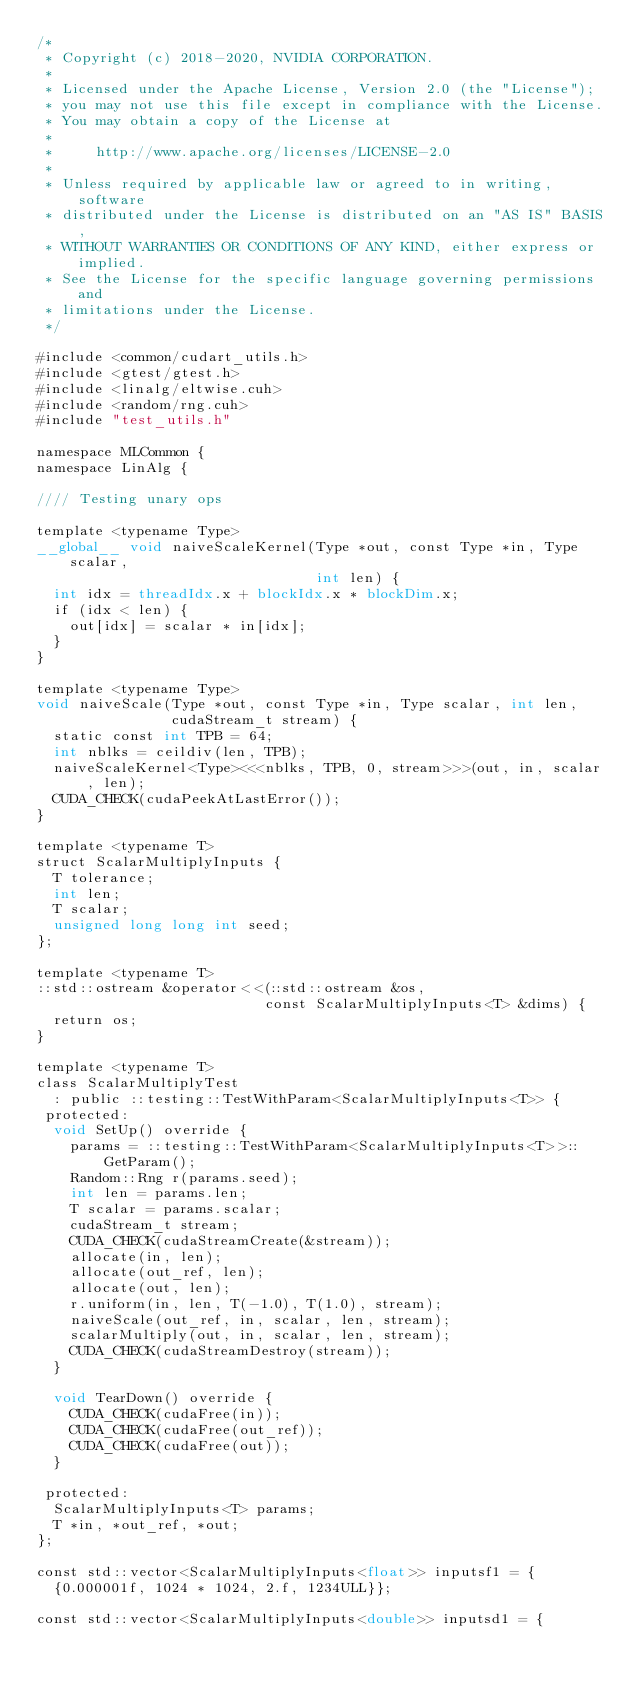<code> <loc_0><loc_0><loc_500><loc_500><_Cuda_>/*
 * Copyright (c) 2018-2020, NVIDIA CORPORATION.
 *
 * Licensed under the Apache License, Version 2.0 (the "License");
 * you may not use this file except in compliance with the License.
 * You may obtain a copy of the License at
 *
 *     http://www.apache.org/licenses/LICENSE-2.0
 *
 * Unless required by applicable law or agreed to in writing, software
 * distributed under the License is distributed on an "AS IS" BASIS,
 * WITHOUT WARRANTIES OR CONDITIONS OF ANY KIND, either express or implied.
 * See the License for the specific language governing permissions and
 * limitations under the License.
 */

#include <common/cudart_utils.h>
#include <gtest/gtest.h>
#include <linalg/eltwise.cuh>
#include <random/rng.cuh>
#include "test_utils.h"

namespace MLCommon {
namespace LinAlg {

//// Testing unary ops

template <typename Type>
__global__ void naiveScaleKernel(Type *out, const Type *in, Type scalar,
                                 int len) {
  int idx = threadIdx.x + blockIdx.x * blockDim.x;
  if (idx < len) {
    out[idx] = scalar * in[idx];
  }
}

template <typename Type>
void naiveScale(Type *out, const Type *in, Type scalar, int len,
                cudaStream_t stream) {
  static const int TPB = 64;
  int nblks = ceildiv(len, TPB);
  naiveScaleKernel<Type><<<nblks, TPB, 0, stream>>>(out, in, scalar, len);
  CUDA_CHECK(cudaPeekAtLastError());
}

template <typename T>
struct ScalarMultiplyInputs {
  T tolerance;
  int len;
  T scalar;
  unsigned long long int seed;
};

template <typename T>
::std::ostream &operator<<(::std::ostream &os,
                           const ScalarMultiplyInputs<T> &dims) {
  return os;
}

template <typename T>
class ScalarMultiplyTest
  : public ::testing::TestWithParam<ScalarMultiplyInputs<T>> {
 protected:
  void SetUp() override {
    params = ::testing::TestWithParam<ScalarMultiplyInputs<T>>::GetParam();
    Random::Rng r(params.seed);
    int len = params.len;
    T scalar = params.scalar;
    cudaStream_t stream;
    CUDA_CHECK(cudaStreamCreate(&stream));
    allocate(in, len);
    allocate(out_ref, len);
    allocate(out, len);
    r.uniform(in, len, T(-1.0), T(1.0), stream);
    naiveScale(out_ref, in, scalar, len, stream);
    scalarMultiply(out, in, scalar, len, stream);
    CUDA_CHECK(cudaStreamDestroy(stream));
  }

  void TearDown() override {
    CUDA_CHECK(cudaFree(in));
    CUDA_CHECK(cudaFree(out_ref));
    CUDA_CHECK(cudaFree(out));
  }

 protected:
  ScalarMultiplyInputs<T> params;
  T *in, *out_ref, *out;
};

const std::vector<ScalarMultiplyInputs<float>> inputsf1 = {
  {0.000001f, 1024 * 1024, 2.f, 1234ULL}};

const std::vector<ScalarMultiplyInputs<double>> inputsd1 = {</code> 